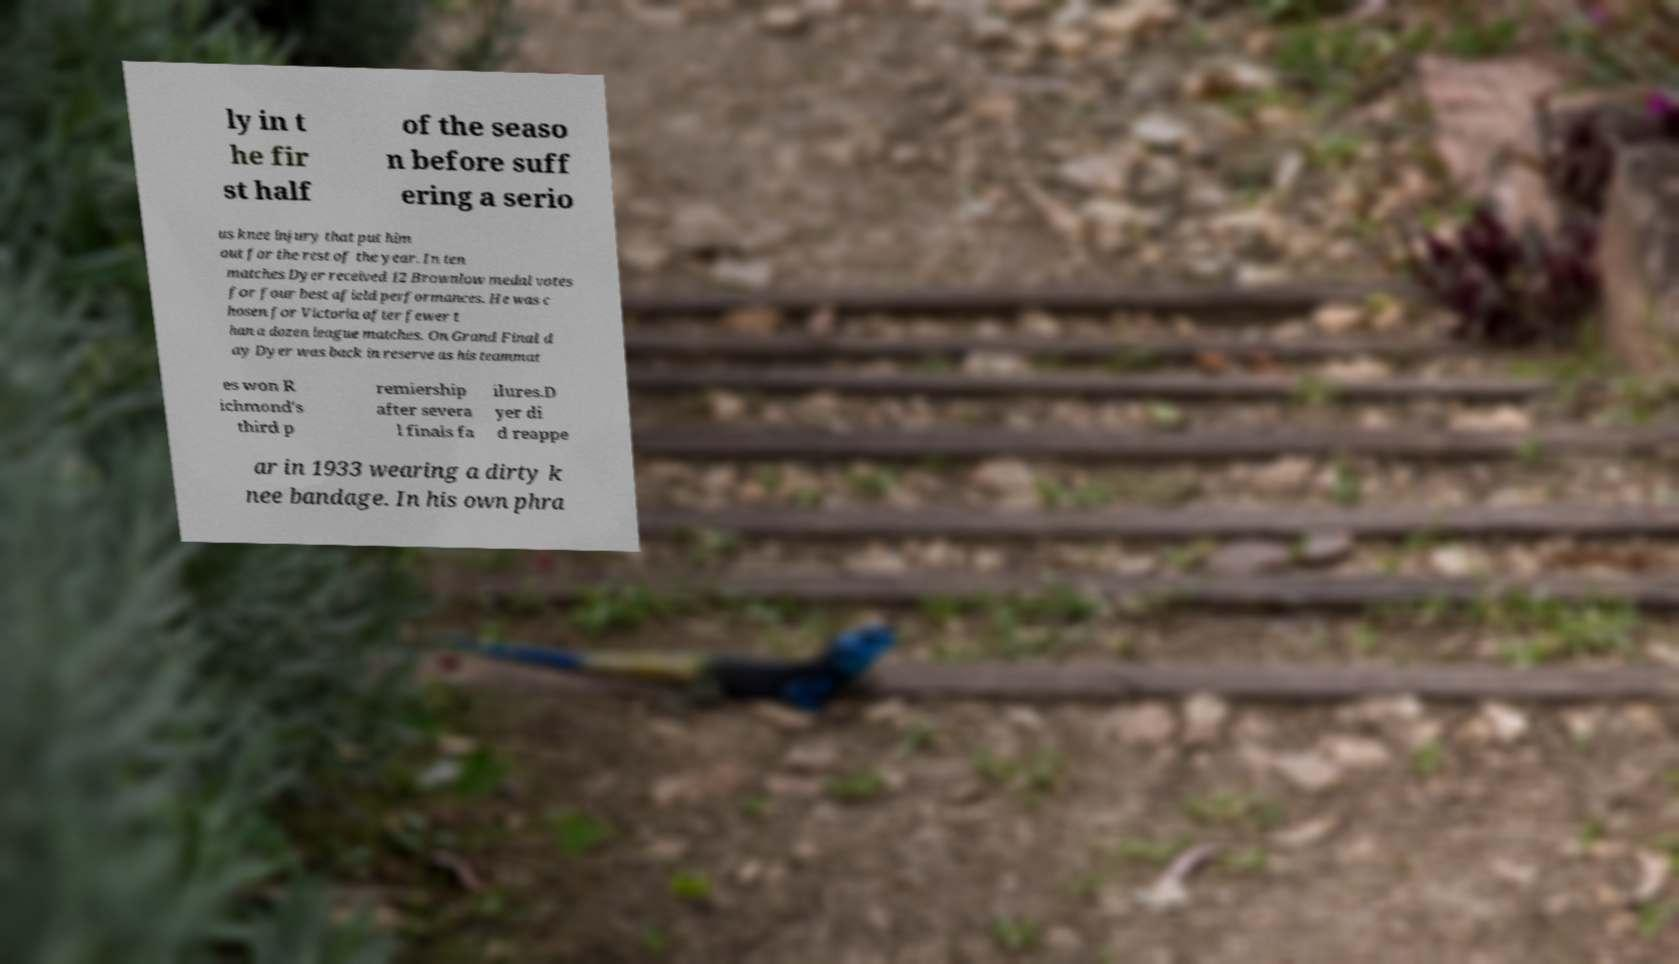Please read and relay the text visible in this image. What does it say? ly in t he fir st half of the seaso n before suff ering a serio us knee injury that put him out for the rest of the year. In ten matches Dyer received 12 Brownlow medal votes for four best afield performances. He was c hosen for Victoria after fewer t han a dozen league matches. On Grand Final d ay Dyer was back in reserve as his teammat es won R ichmond's third p remiership after severa l finals fa ilures.D yer di d reappe ar in 1933 wearing a dirty k nee bandage. In his own phra 